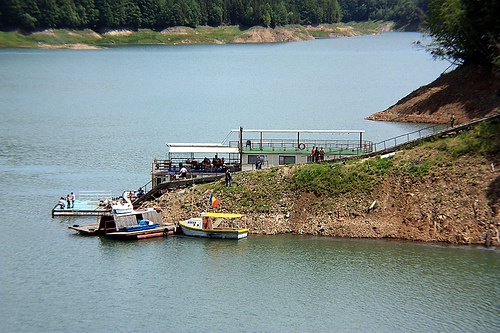Describe the objects in this image and their specific colors. I can see boat in black, darkgray, white, and khaki tones, boat in black, gray, white, and yellow tones, people in black, gray, maroon, and white tones, people in black, darkgreen, gray, and darkgray tones, and people in black, gray, and navy tones in this image. 